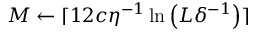Convert formula to latex. <formula><loc_0><loc_0><loc_500><loc_500>M \gets \lceil 1 2 c \eta ^ { - 1 } \ln \left ( L \delta ^ { - 1 } \right ) \rceil</formula> 